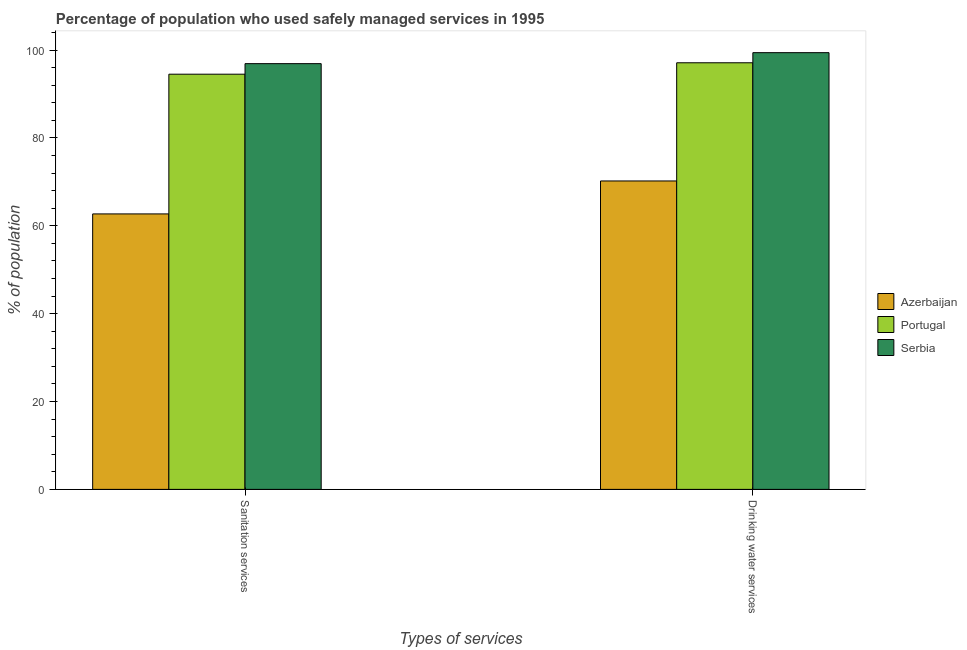Are the number of bars on each tick of the X-axis equal?
Your answer should be very brief. Yes. How many bars are there on the 2nd tick from the left?
Your response must be concise. 3. How many bars are there on the 2nd tick from the right?
Ensure brevity in your answer.  3. What is the label of the 2nd group of bars from the left?
Your answer should be compact. Drinking water services. What is the percentage of population who used drinking water services in Azerbaijan?
Make the answer very short. 70.2. Across all countries, what is the maximum percentage of population who used drinking water services?
Keep it short and to the point. 99.4. Across all countries, what is the minimum percentage of population who used sanitation services?
Offer a very short reply. 62.7. In which country was the percentage of population who used sanitation services maximum?
Offer a terse response. Serbia. In which country was the percentage of population who used sanitation services minimum?
Keep it short and to the point. Azerbaijan. What is the total percentage of population who used sanitation services in the graph?
Give a very brief answer. 254.1. What is the difference between the percentage of population who used drinking water services in Portugal and that in Azerbaijan?
Your response must be concise. 26.9. What is the difference between the percentage of population who used sanitation services in Azerbaijan and the percentage of population who used drinking water services in Portugal?
Give a very brief answer. -34.4. What is the average percentage of population who used drinking water services per country?
Give a very brief answer. 88.9. What is the difference between the percentage of population who used sanitation services and percentage of population who used drinking water services in Azerbaijan?
Your answer should be very brief. -7.5. What is the ratio of the percentage of population who used drinking water services in Azerbaijan to that in Portugal?
Your response must be concise. 0.72. What does the 1st bar from the left in Sanitation services represents?
Your response must be concise. Azerbaijan. What does the 2nd bar from the right in Drinking water services represents?
Ensure brevity in your answer.  Portugal. How many bars are there?
Keep it short and to the point. 6. Are all the bars in the graph horizontal?
Your answer should be compact. No. What is the difference between two consecutive major ticks on the Y-axis?
Provide a short and direct response. 20. Are the values on the major ticks of Y-axis written in scientific E-notation?
Ensure brevity in your answer.  No. Where does the legend appear in the graph?
Make the answer very short. Center right. How many legend labels are there?
Give a very brief answer. 3. How are the legend labels stacked?
Give a very brief answer. Vertical. What is the title of the graph?
Your response must be concise. Percentage of population who used safely managed services in 1995. What is the label or title of the X-axis?
Ensure brevity in your answer.  Types of services. What is the label or title of the Y-axis?
Your answer should be very brief. % of population. What is the % of population in Azerbaijan in Sanitation services?
Provide a short and direct response. 62.7. What is the % of population in Portugal in Sanitation services?
Your response must be concise. 94.5. What is the % of population of Serbia in Sanitation services?
Your response must be concise. 96.9. What is the % of population in Azerbaijan in Drinking water services?
Ensure brevity in your answer.  70.2. What is the % of population of Portugal in Drinking water services?
Provide a short and direct response. 97.1. What is the % of population in Serbia in Drinking water services?
Your answer should be compact. 99.4. Across all Types of services, what is the maximum % of population in Azerbaijan?
Ensure brevity in your answer.  70.2. Across all Types of services, what is the maximum % of population in Portugal?
Your answer should be very brief. 97.1. Across all Types of services, what is the maximum % of population of Serbia?
Provide a short and direct response. 99.4. Across all Types of services, what is the minimum % of population in Azerbaijan?
Your answer should be very brief. 62.7. Across all Types of services, what is the minimum % of population of Portugal?
Make the answer very short. 94.5. Across all Types of services, what is the minimum % of population in Serbia?
Your response must be concise. 96.9. What is the total % of population of Azerbaijan in the graph?
Keep it short and to the point. 132.9. What is the total % of population of Portugal in the graph?
Make the answer very short. 191.6. What is the total % of population in Serbia in the graph?
Provide a succinct answer. 196.3. What is the difference between the % of population in Azerbaijan in Sanitation services and that in Drinking water services?
Offer a very short reply. -7.5. What is the difference between the % of population of Portugal in Sanitation services and that in Drinking water services?
Make the answer very short. -2.6. What is the difference between the % of population in Serbia in Sanitation services and that in Drinking water services?
Give a very brief answer. -2.5. What is the difference between the % of population in Azerbaijan in Sanitation services and the % of population in Portugal in Drinking water services?
Your response must be concise. -34.4. What is the difference between the % of population in Azerbaijan in Sanitation services and the % of population in Serbia in Drinking water services?
Provide a short and direct response. -36.7. What is the average % of population in Azerbaijan per Types of services?
Your answer should be very brief. 66.45. What is the average % of population in Portugal per Types of services?
Your answer should be compact. 95.8. What is the average % of population in Serbia per Types of services?
Your answer should be compact. 98.15. What is the difference between the % of population in Azerbaijan and % of population in Portugal in Sanitation services?
Your response must be concise. -31.8. What is the difference between the % of population in Azerbaijan and % of population in Serbia in Sanitation services?
Your response must be concise. -34.2. What is the difference between the % of population of Azerbaijan and % of population of Portugal in Drinking water services?
Your response must be concise. -26.9. What is the difference between the % of population in Azerbaijan and % of population in Serbia in Drinking water services?
Provide a succinct answer. -29.2. What is the difference between the % of population in Portugal and % of population in Serbia in Drinking water services?
Your answer should be very brief. -2.3. What is the ratio of the % of population of Azerbaijan in Sanitation services to that in Drinking water services?
Offer a terse response. 0.89. What is the ratio of the % of population in Portugal in Sanitation services to that in Drinking water services?
Offer a terse response. 0.97. What is the ratio of the % of population of Serbia in Sanitation services to that in Drinking water services?
Provide a succinct answer. 0.97. What is the difference between the highest and the second highest % of population in Azerbaijan?
Keep it short and to the point. 7.5. 